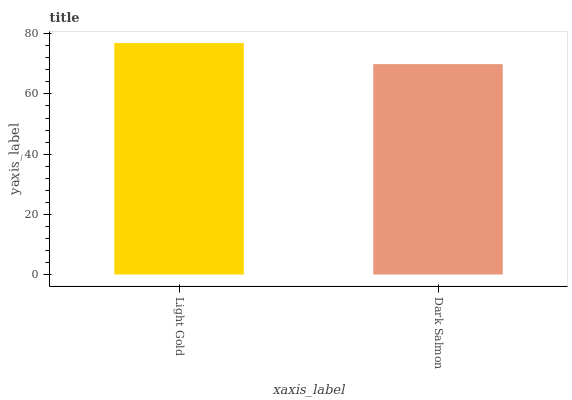Is Dark Salmon the minimum?
Answer yes or no. Yes. Is Light Gold the maximum?
Answer yes or no. Yes. Is Dark Salmon the maximum?
Answer yes or no. No. Is Light Gold greater than Dark Salmon?
Answer yes or no. Yes. Is Dark Salmon less than Light Gold?
Answer yes or no. Yes. Is Dark Salmon greater than Light Gold?
Answer yes or no. No. Is Light Gold less than Dark Salmon?
Answer yes or no. No. Is Light Gold the high median?
Answer yes or no. Yes. Is Dark Salmon the low median?
Answer yes or no. Yes. Is Dark Salmon the high median?
Answer yes or no. No. Is Light Gold the low median?
Answer yes or no. No. 